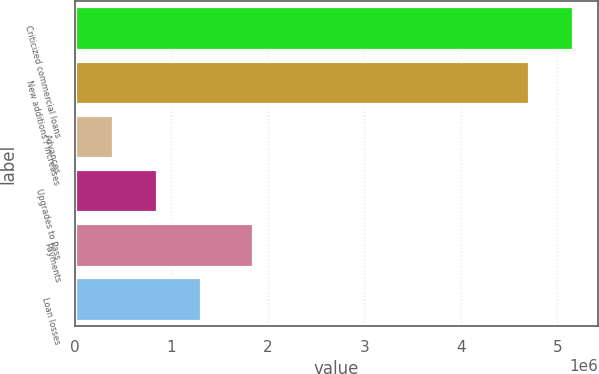Convert chart. <chart><loc_0><loc_0><loc_500><loc_500><bar_chart><fcel>Criticized commercial loans<fcel>New additions / increases<fcel>Advances<fcel>Upgrades to Pass<fcel>Payments<fcel>Loan losses<nl><fcel>5.16559e+06<fcel>4.70752e+06<fcel>390872<fcel>848948<fcel>1.84354e+06<fcel>1.30702e+06<nl></chart> 